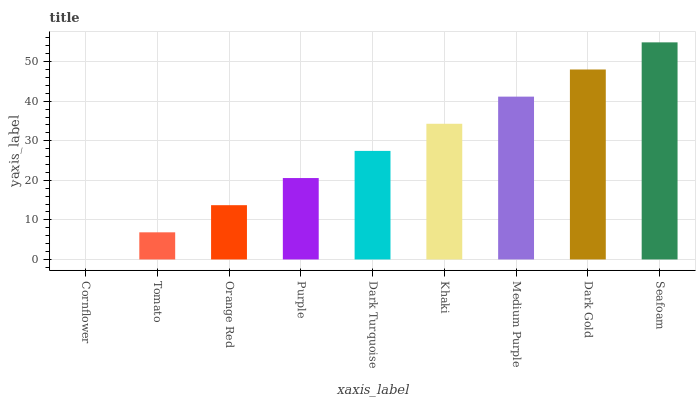Is Cornflower the minimum?
Answer yes or no. Yes. Is Seafoam the maximum?
Answer yes or no. Yes. Is Tomato the minimum?
Answer yes or no. No. Is Tomato the maximum?
Answer yes or no. No. Is Tomato greater than Cornflower?
Answer yes or no. Yes. Is Cornflower less than Tomato?
Answer yes or no. Yes. Is Cornflower greater than Tomato?
Answer yes or no. No. Is Tomato less than Cornflower?
Answer yes or no. No. Is Dark Turquoise the high median?
Answer yes or no. Yes. Is Dark Turquoise the low median?
Answer yes or no. Yes. Is Khaki the high median?
Answer yes or no. No. Is Orange Red the low median?
Answer yes or no. No. 